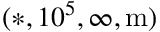Convert formula to latex. <formula><loc_0><loc_0><loc_500><loc_500>( * , 1 0 ^ { 5 } , \infty , m )</formula> 